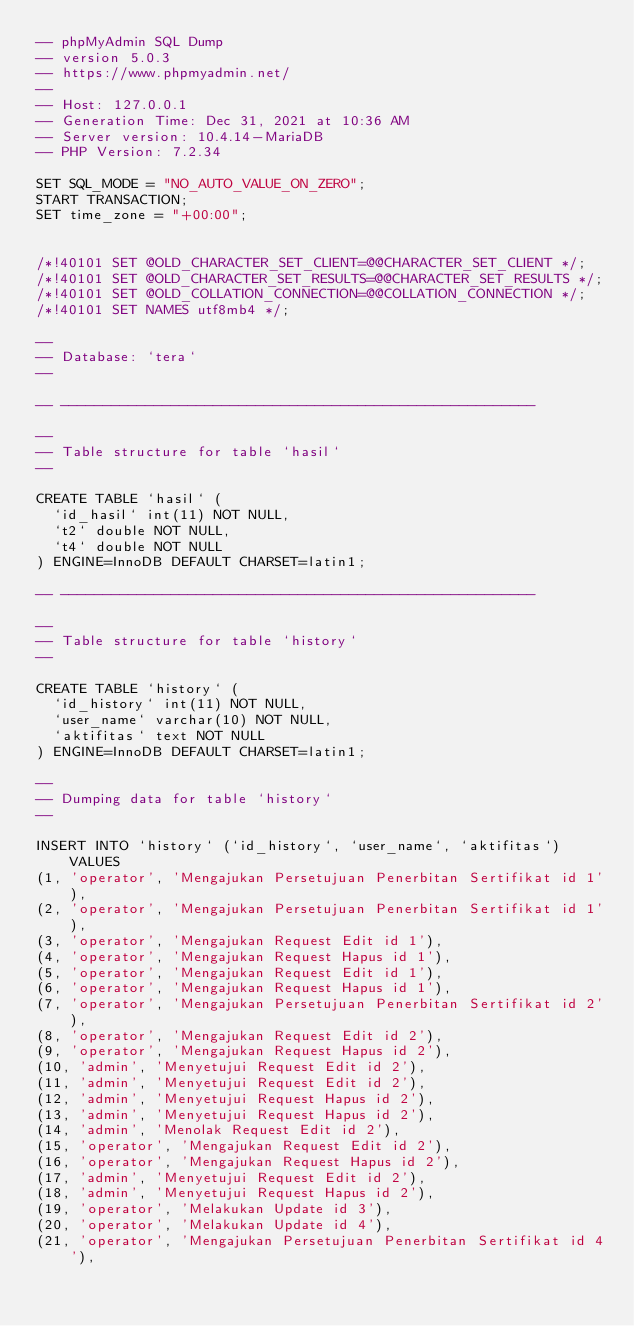Convert code to text. <code><loc_0><loc_0><loc_500><loc_500><_SQL_>-- phpMyAdmin SQL Dump
-- version 5.0.3
-- https://www.phpmyadmin.net/
--
-- Host: 127.0.0.1
-- Generation Time: Dec 31, 2021 at 10:36 AM
-- Server version: 10.4.14-MariaDB
-- PHP Version: 7.2.34

SET SQL_MODE = "NO_AUTO_VALUE_ON_ZERO";
START TRANSACTION;
SET time_zone = "+00:00";


/*!40101 SET @OLD_CHARACTER_SET_CLIENT=@@CHARACTER_SET_CLIENT */;
/*!40101 SET @OLD_CHARACTER_SET_RESULTS=@@CHARACTER_SET_RESULTS */;
/*!40101 SET @OLD_COLLATION_CONNECTION=@@COLLATION_CONNECTION */;
/*!40101 SET NAMES utf8mb4 */;

--
-- Database: `tera`
--

-- --------------------------------------------------------

--
-- Table structure for table `hasil`
--

CREATE TABLE `hasil` (
  `id_hasil` int(11) NOT NULL,
  `t2` double NOT NULL,
  `t4` double NOT NULL
) ENGINE=InnoDB DEFAULT CHARSET=latin1;

-- --------------------------------------------------------

--
-- Table structure for table `history`
--

CREATE TABLE `history` (
  `id_history` int(11) NOT NULL,
  `user_name` varchar(10) NOT NULL,
  `aktifitas` text NOT NULL
) ENGINE=InnoDB DEFAULT CHARSET=latin1;

--
-- Dumping data for table `history`
--

INSERT INTO `history` (`id_history`, `user_name`, `aktifitas`) VALUES
(1, 'operator', 'Mengajukan Persetujuan Penerbitan Sertifikat id 1'),
(2, 'operator', 'Mengajukan Persetujuan Penerbitan Sertifikat id 1'),
(3, 'operator', 'Mengajukan Request Edit id 1'),
(4, 'operator', 'Mengajukan Request Hapus id 1'),
(5, 'operator', 'Mengajukan Request Edit id 1'),
(6, 'operator', 'Mengajukan Request Hapus id 1'),
(7, 'operator', 'Mengajukan Persetujuan Penerbitan Sertifikat id 2'),
(8, 'operator', 'Mengajukan Request Edit id 2'),
(9, 'operator', 'Mengajukan Request Hapus id 2'),
(10, 'admin', 'Menyetujui Request Edit id 2'),
(11, 'admin', 'Menyetujui Request Edit id 2'),
(12, 'admin', 'Menyetujui Request Hapus id 2'),
(13, 'admin', 'Menyetujui Request Hapus id 2'),
(14, 'admin', 'Menolak Request Edit id 2'),
(15, 'operator', 'Mengajukan Request Edit id 2'),
(16, 'operator', 'Mengajukan Request Hapus id 2'),
(17, 'admin', 'Menyetujui Request Edit id 2'),
(18, 'admin', 'Menyetujui Request Hapus id 2'),
(19, 'operator', 'Melakukan Update id 3'),
(20, 'operator', 'Melakukan Update id 4'),
(21, 'operator', 'Mengajukan Persetujuan Penerbitan Sertifikat id 4'),</code> 